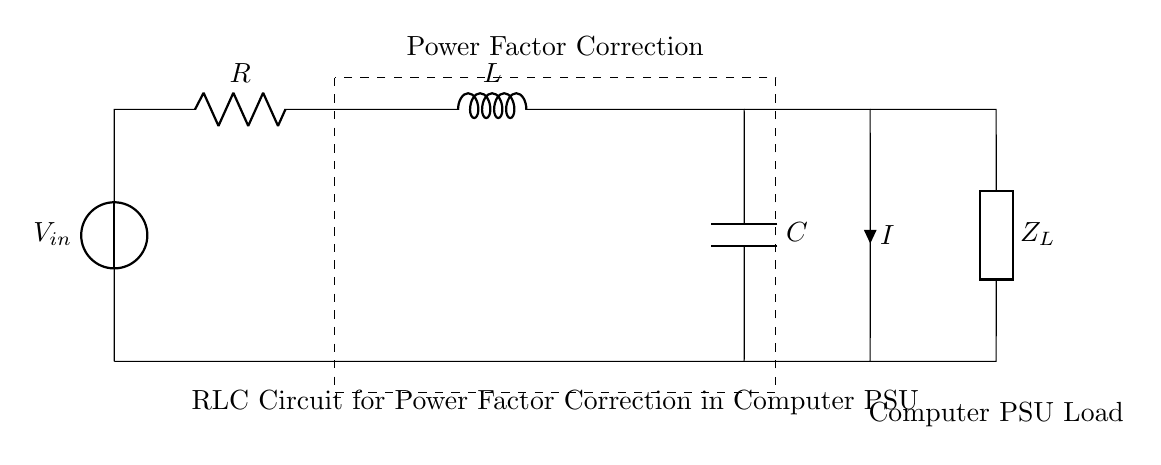What does the voltage source represent? The voltage source labeled as \(V_{in}\) provides the input voltage for the RLC circuit. It is the initial source of electrical energy needed for the circuit to function.
Answer: input voltage What components are present in this circuit? The circuit contains three main components: a resistor, an inductor, and a capacitor, which are all arranged in parallel to the load that requires power.
Answer: resistor, inductor, capacitor What is the purpose of the dashed rectangle in the circuit? The dashed rectangle encloses the components, indicating that they are used together for a specific function, which in this case is for Power Factor Correction within the circuit.
Answer: Power Factor Correction How does this RLC circuit improve power factor? By combining resistance, inductance, and capacitance, this circuit can correct the phase difference between voltage and current, thus improving power factor and making the power supply unit more efficient.
Answer: improves efficiency What is the function of the load \(Z_L\)? The load labeled \(Z_L\) represents the total impedance of the connected computer power supply unit that consumes the output power from the RLC circuit.
Answer: total impedance What is the significance of the direction of current \(I\)? The direction of current \(I\) indicates the flow of electric charge through the circuit, showing how power is delivered from the source through the components to the load.
Answer: direction of flow What effect does the inductor have on the circuit? The inductor stores energy in a magnetic field when current passes through it, which can manage the power supply's reactive power and mitigate phase shifts in the circuit.
Answer: stores energy 